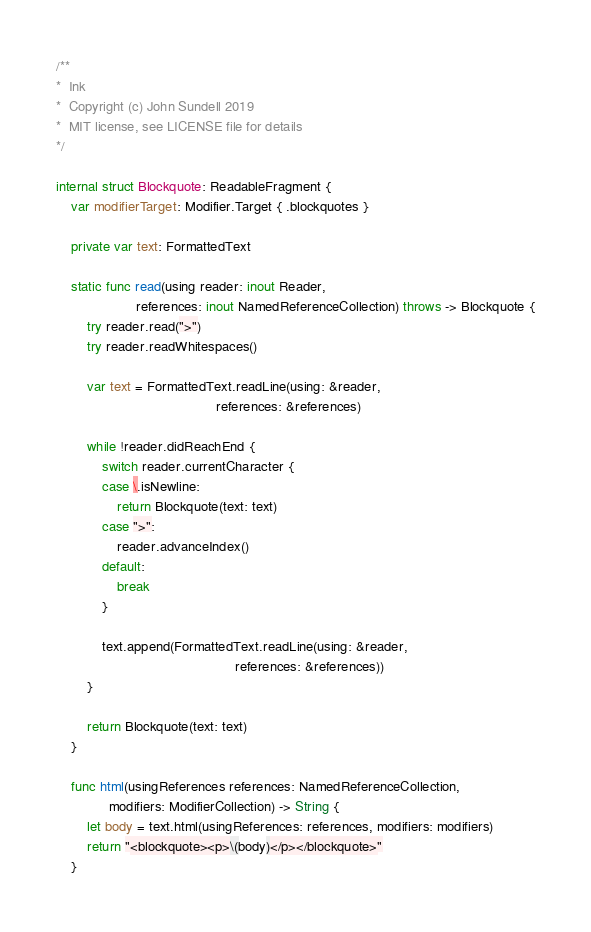Convert code to text. <code><loc_0><loc_0><loc_500><loc_500><_Swift_>/**
*  Ink
*  Copyright (c) John Sundell 2019
*  MIT license, see LICENSE file for details
*/

internal struct Blockquote: ReadableFragment {
    var modifierTarget: Modifier.Target { .blockquotes }

    private var text: FormattedText

    static func read(using reader: inout Reader,
                     references: inout NamedReferenceCollection) throws -> Blockquote {
        try reader.read(">")
        try reader.readWhitespaces()

        var text = FormattedText.readLine(using: &reader,
                                          references: &references)

        while !reader.didReachEnd {
            switch reader.currentCharacter {
            case \.isNewline:
                return Blockquote(text: text)
            case ">":
                reader.advanceIndex()
            default:
                break
            }

            text.append(FormattedText.readLine(using: &reader,
                                               references: &references))
        }

        return Blockquote(text: text)
    }

    func html(usingReferences references: NamedReferenceCollection,
              modifiers: ModifierCollection) -> String {
        let body = text.html(usingReferences: references, modifiers: modifiers)
        return "<blockquote><p>\(body)</p></blockquote>"
    }
</code> 